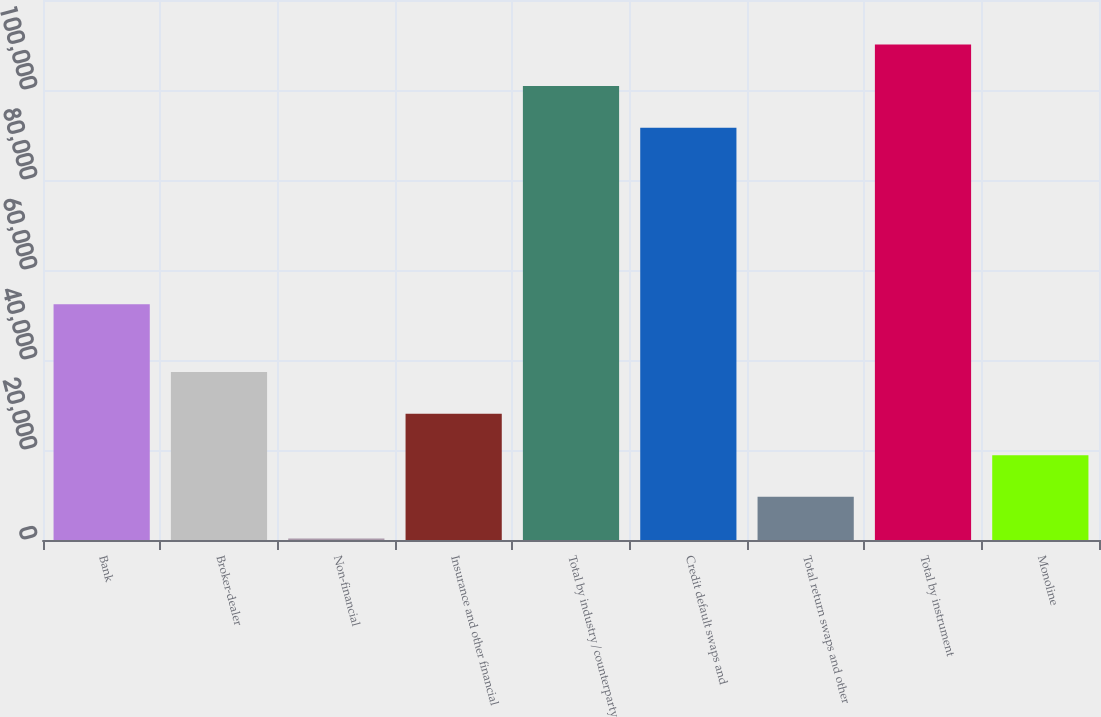Convert chart to OTSL. <chart><loc_0><loc_0><loc_500><loc_500><bar_chart><fcel>Bank<fcel>Broker-dealer<fcel>Non-financial<fcel>Insurance and other financial<fcel>Total by industry/counterparty<fcel>Credit default swaps and<fcel>Total return swaps and other<fcel>Total by instrument<fcel>Monoline<nl><fcel>52383<fcel>37320.2<fcel>339<fcel>28074.9<fcel>100870<fcel>91625<fcel>9584.3<fcel>110116<fcel>18829.6<nl></chart> 